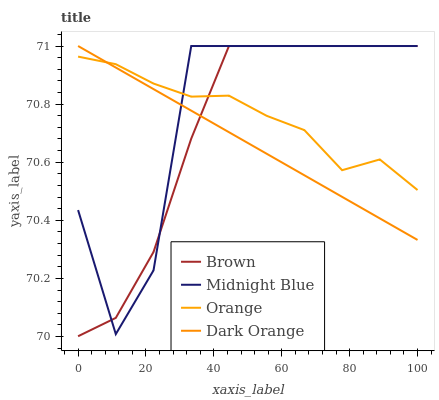Does Dark Orange have the minimum area under the curve?
Answer yes or no. Yes. Does Midnight Blue have the maximum area under the curve?
Answer yes or no. Yes. Does Brown have the minimum area under the curve?
Answer yes or no. No. Does Brown have the maximum area under the curve?
Answer yes or no. No. Is Dark Orange the smoothest?
Answer yes or no. Yes. Is Midnight Blue the roughest?
Answer yes or no. Yes. Is Brown the smoothest?
Answer yes or no. No. Is Brown the roughest?
Answer yes or no. No. Does Midnight Blue have the lowest value?
Answer yes or no. No. Does Dark Orange have the highest value?
Answer yes or no. Yes. 